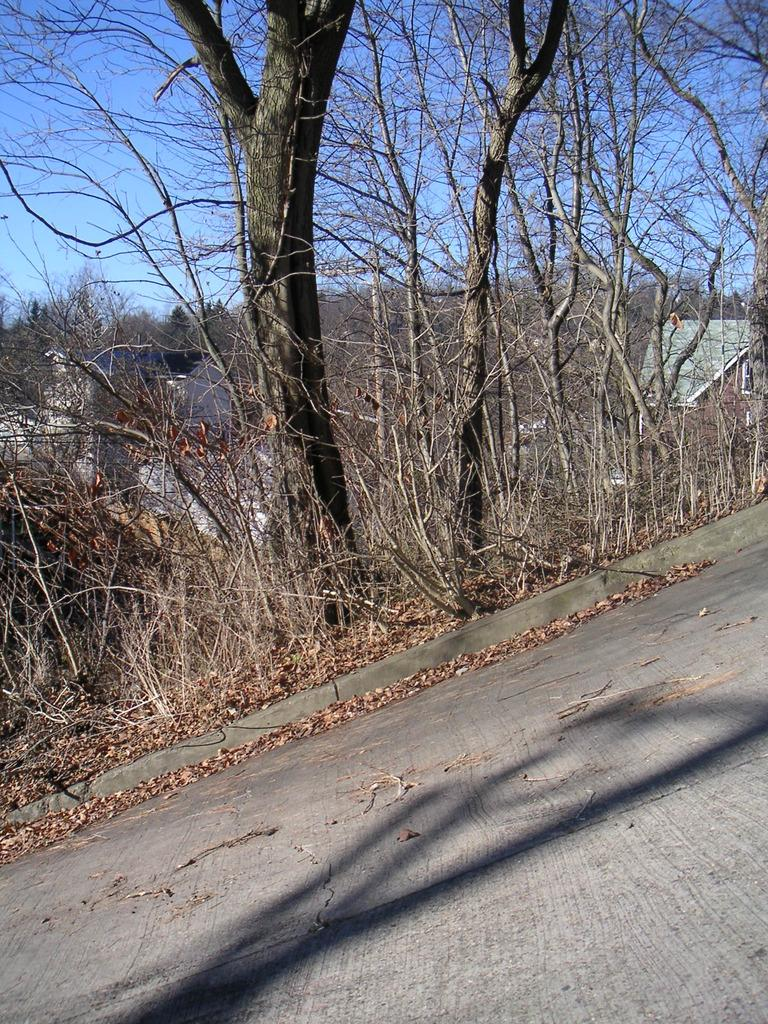What is the main feature of the image? There is a road in the image. What type of vegetation can be seen in the image? There are dry trees in the image. What can be seen in the distance in the image? There are buildings visible in the background of the image. What type of wilderness can be seen in the image? There is no wilderness present in the image; it features a road, dry trees, and buildings. Is the image based on a fictional setting? The image is not based on a fictional setting; it appears to be a real-life scene. 